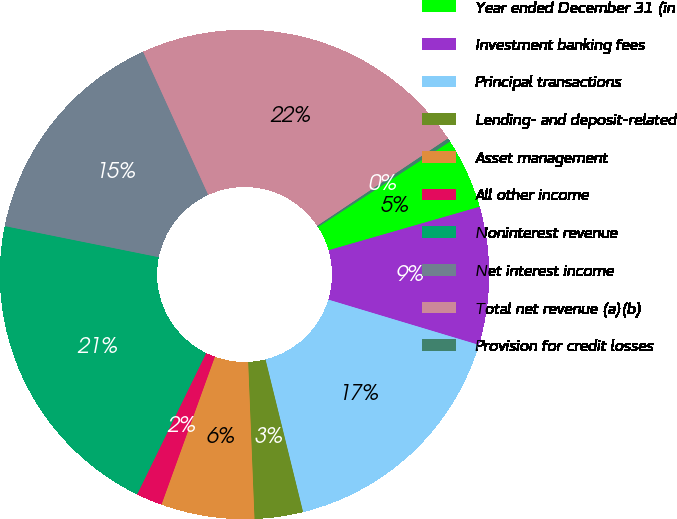Convert chart. <chart><loc_0><loc_0><loc_500><loc_500><pie_chart><fcel>Year ended December 31 (in<fcel>Investment banking fees<fcel>Principal transactions<fcel>Lending- and deposit-related<fcel>Asset management<fcel>All other income<fcel>Noninterest revenue<fcel>Net interest income<fcel>Total net revenue (a)(b)<fcel>Provision for credit losses<nl><fcel>4.68%<fcel>9.11%<fcel>16.51%<fcel>3.2%<fcel>6.16%<fcel>1.72%<fcel>20.94%<fcel>15.03%<fcel>22.42%<fcel>0.24%<nl></chart> 